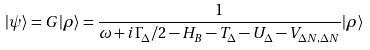<formula> <loc_0><loc_0><loc_500><loc_500>| \psi \rangle = G | \rho \rangle = \frac { 1 } { \omega + i \Gamma _ { \Delta } / 2 - H _ { B } - T _ { \Delta } - U _ { \Delta } - V _ { \Delta N , \Delta N } } | \rho \rangle</formula> 